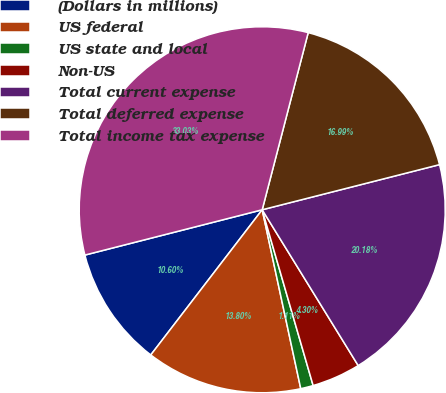<chart> <loc_0><loc_0><loc_500><loc_500><pie_chart><fcel>(Dollars in millions)<fcel>US federal<fcel>US state and local<fcel>Non-US<fcel>Total current expense<fcel>Total deferred expense<fcel>Total income tax expense<nl><fcel>10.6%<fcel>13.8%<fcel>1.11%<fcel>4.3%<fcel>20.18%<fcel>16.99%<fcel>33.03%<nl></chart> 